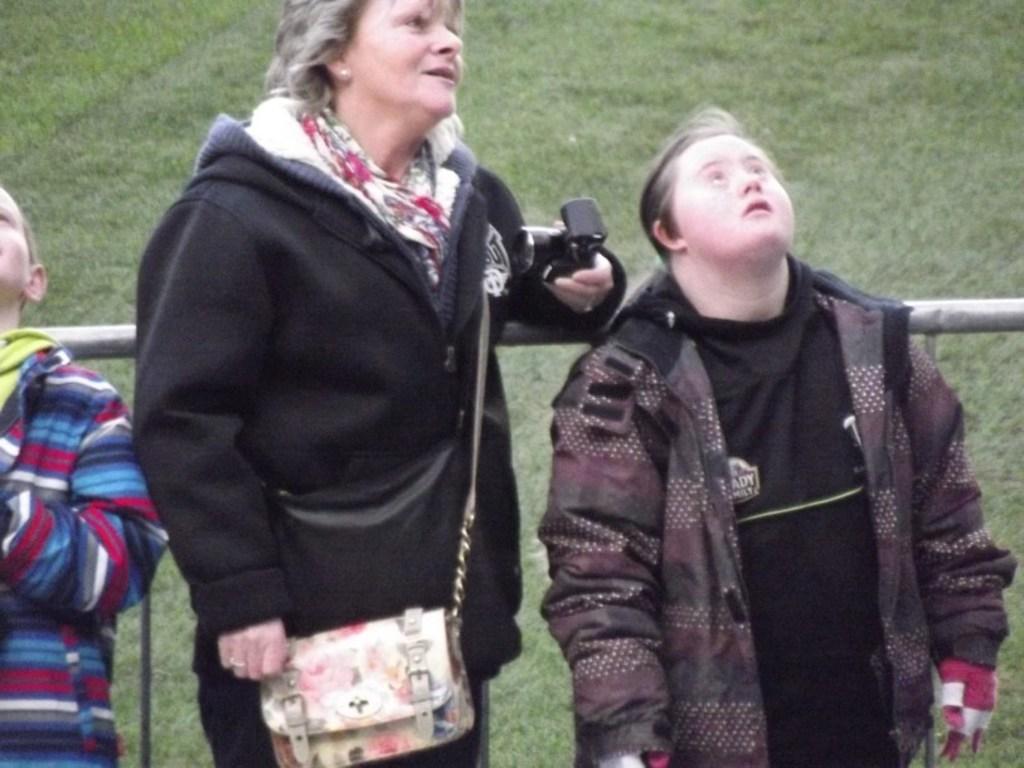Describe this image in one or two sentences. Here in this picture we can see three people standing on the ground over there and the woman in the middle is having a hand bag with her and she is holding a camera in her hand and we can see all of them are wearing jackets on them and behind them we can see a railing and we can see the ground is covered with grass all over there. 